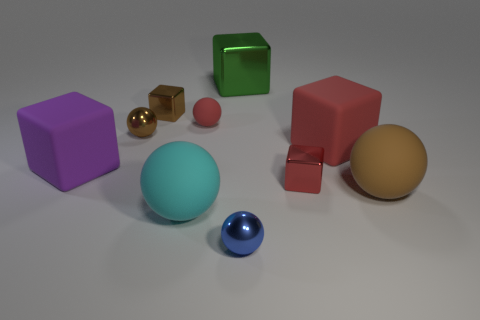How many objects are either large gray cylinders or blue things? Upon examining the image, I see one large gray cylinder and two blue objects - a small sphere and a large sphere. Therefore, in total, there are three objects that meet the criteria of being either large gray cylinders or blue things. 